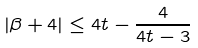<formula> <loc_0><loc_0><loc_500><loc_500>| \beta + 4 | \leq 4 t - \frac { 4 } { 4 t - 3 }</formula> 